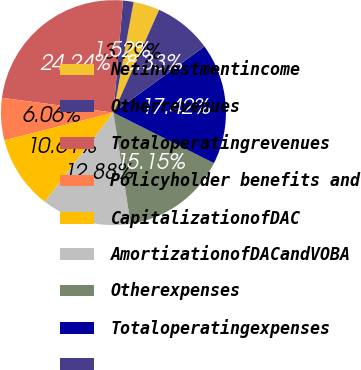Convert chart to OTSL. <chart><loc_0><loc_0><loc_500><loc_500><pie_chart><fcel>Netinvestmentincome<fcel>Otherrevenues<fcel>Totaloperatingrevenues<fcel>Policyholder benefits and<fcel>CapitalizationofDAC<fcel>AmortizationofDACandVOBA<fcel>Otherexpenses<fcel>Totaloperatingexpenses<fcel>Unnamed: 8<nl><fcel>3.79%<fcel>1.52%<fcel>24.24%<fcel>6.06%<fcel>10.61%<fcel>12.88%<fcel>15.15%<fcel>17.42%<fcel>8.33%<nl></chart> 